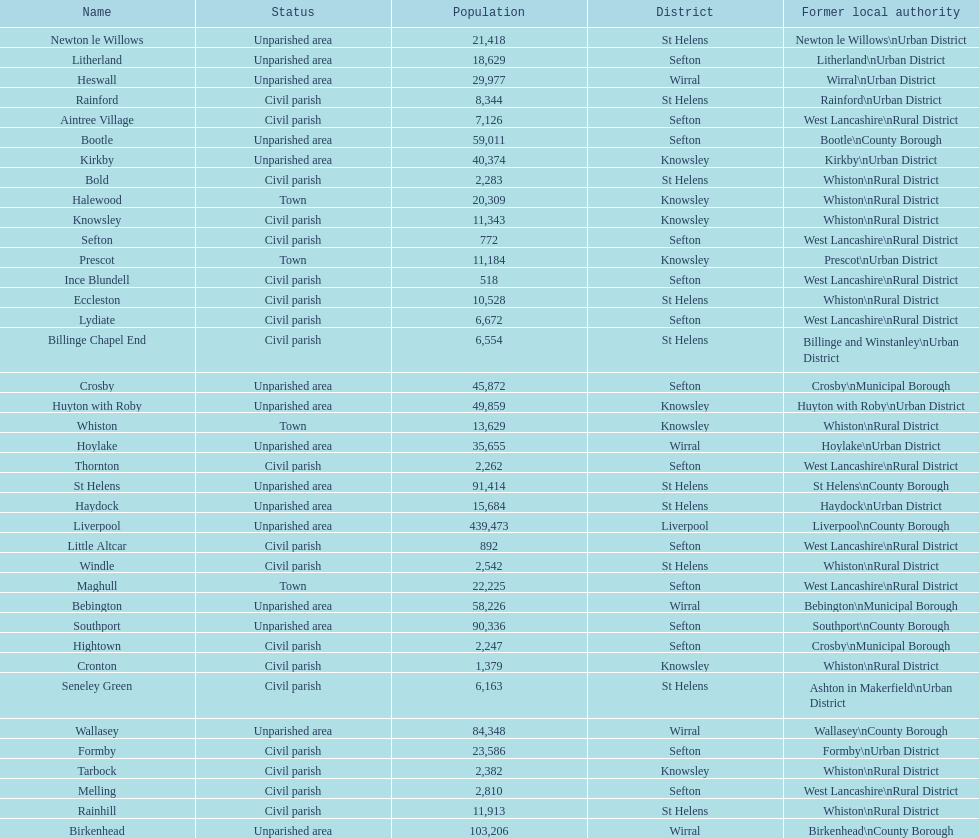How many people live in the bold civil parish? 2,283. 